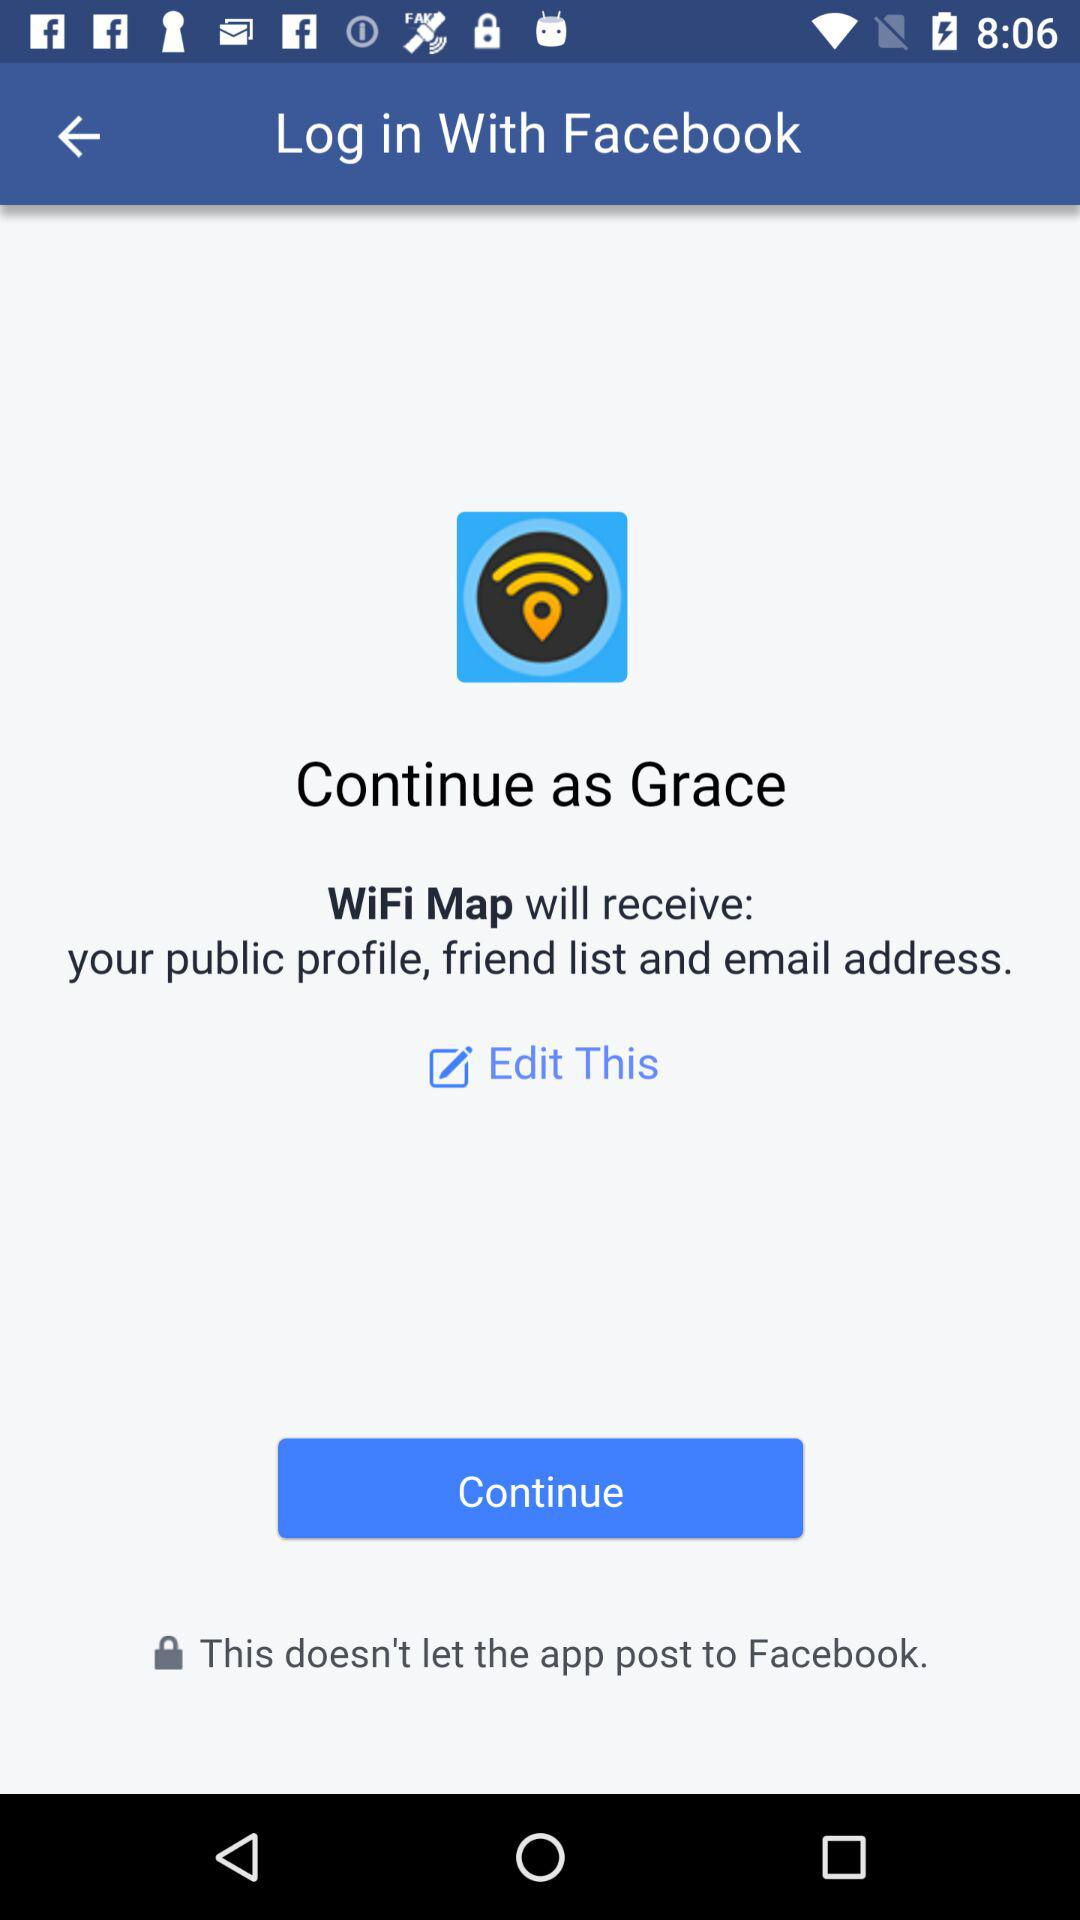What application is asking for permission? The application asking for permission is "WiFi Map". 